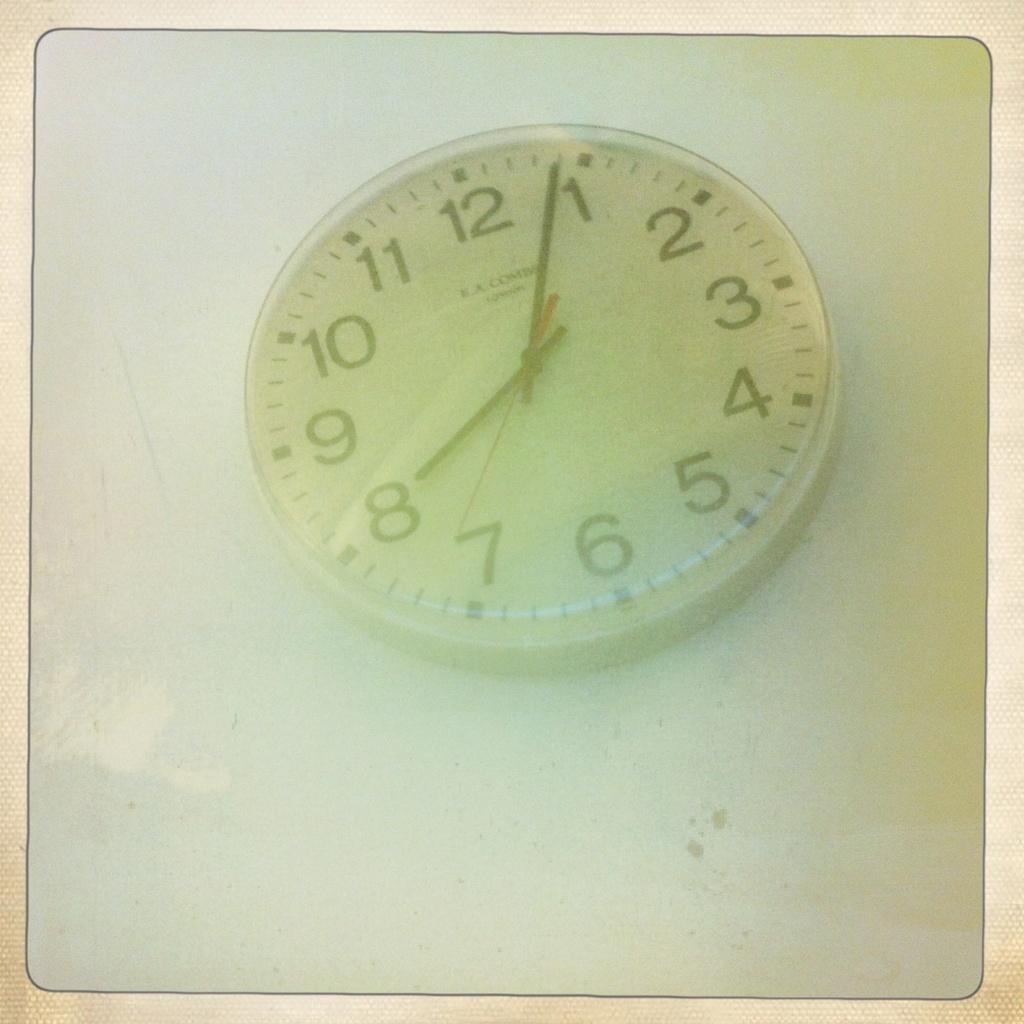What number has the seconds hand recently passed?
Keep it short and to the point. 7. 